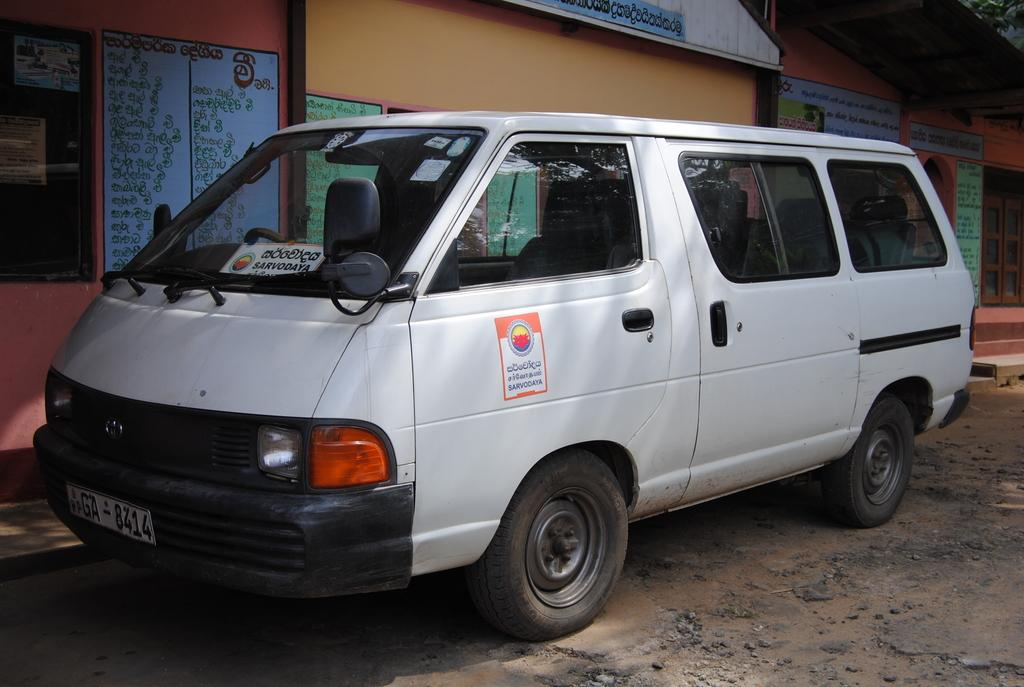What is the main subject in the picture? There is a vehicle in the picture. What else can be seen in the picture besides the vehicle? There are houses and walls present in the picture. Can you describe the walls in the picture? The walls have text on them. What type of reward is being given to the snow in the picture? There is no snow present in the picture, and therefore no reward can be given to it. Can you tell me how many eggs are in the eggnog in the picture? There is no eggnog present in the picture, so it is impossible to determine the number of eggs in it. 